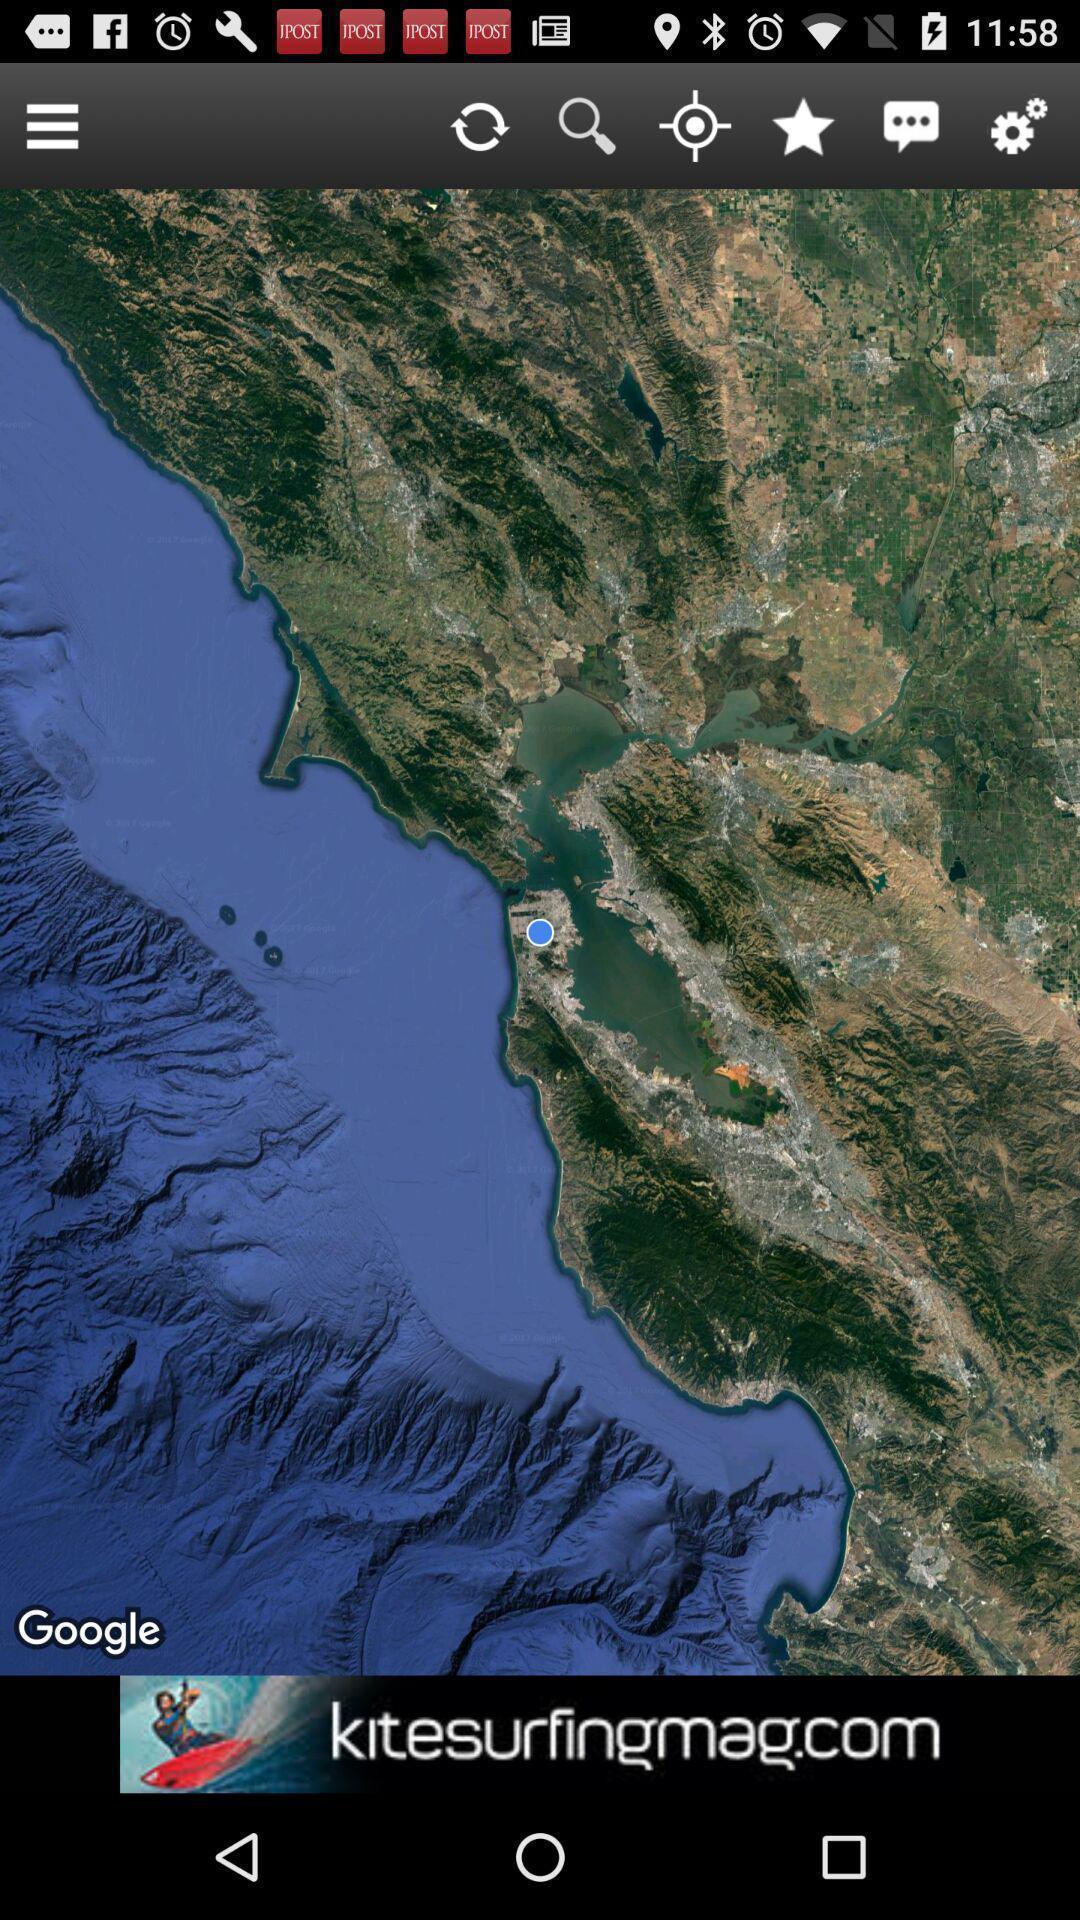Summarize the main components in this picture. Page displays options in weather app. 